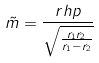Convert formula to latex. <formula><loc_0><loc_0><loc_500><loc_500>\tilde { m } = \frac { r h p } { \sqrt { \frac { r _ { 1 } r _ { 2 } } { r _ { 1 } - r _ { 2 } } } }</formula> 